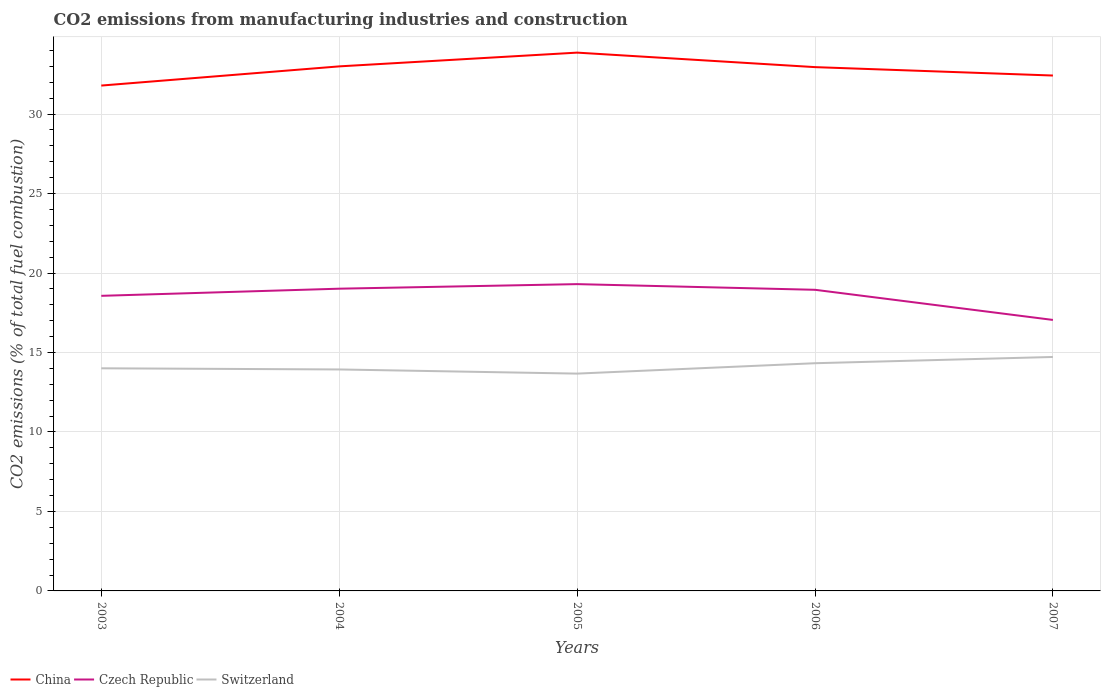How many different coloured lines are there?
Your response must be concise. 3. Does the line corresponding to Czech Republic intersect with the line corresponding to China?
Offer a terse response. No. Across all years, what is the maximum amount of CO2 emitted in Switzerland?
Offer a terse response. 13.67. In which year was the amount of CO2 emitted in Czech Republic maximum?
Make the answer very short. 2007. What is the total amount of CO2 emitted in Czech Republic in the graph?
Offer a very short reply. -0.29. What is the difference between the highest and the second highest amount of CO2 emitted in Czech Republic?
Offer a terse response. 2.25. How many lines are there?
Provide a short and direct response. 3. Are the values on the major ticks of Y-axis written in scientific E-notation?
Keep it short and to the point. No. Does the graph contain any zero values?
Keep it short and to the point. No. Does the graph contain grids?
Keep it short and to the point. Yes. Where does the legend appear in the graph?
Provide a short and direct response. Bottom left. How many legend labels are there?
Offer a terse response. 3. What is the title of the graph?
Your response must be concise. CO2 emissions from manufacturing industries and construction. Does "Pakistan" appear as one of the legend labels in the graph?
Your answer should be very brief. No. What is the label or title of the Y-axis?
Offer a very short reply. CO2 emissions (% of total fuel combustion). What is the CO2 emissions (% of total fuel combustion) of China in 2003?
Provide a succinct answer. 31.79. What is the CO2 emissions (% of total fuel combustion) of Czech Republic in 2003?
Your response must be concise. 18.56. What is the CO2 emissions (% of total fuel combustion) in Switzerland in 2003?
Offer a very short reply. 14.01. What is the CO2 emissions (% of total fuel combustion) of China in 2004?
Give a very brief answer. 33. What is the CO2 emissions (% of total fuel combustion) in Czech Republic in 2004?
Make the answer very short. 19.01. What is the CO2 emissions (% of total fuel combustion) of Switzerland in 2004?
Your answer should be very brief. 13.93. What is the CO2 emissions (% of total fuel combustion) of China in 2005?
Your answer should be compact. 33.86. What is the CO2 emissions (% of total fuel combustion) in Czech Republic in 2005?
Ensure brevity in your answer.  19.3. What is the CO2 emissions (% of total fuel combustion) of Switzerland in 2005?
Your response must be concise. 13.67. What is the CO2 emissions (% of total fuel combustion) in China in 2006?
Offer a terse response. 32.95. What is the CO2 emissions (% of total fuel combustion) of Czech Republic in 2006?
Your response must be concise. 18.94. What is the CO2 emissions (% of total fuel combustion) in Switzerland in 2006?
Provide a short and direct response. 14.32. What is the CO2 emissions (% of total fuel combustion) in China in 2007?
Make the answer very short. 32.42. What is the CO2 emissions (% of total fuel combustion) of Czech Republic in 2007?
Your answer should be compact. 17.05. What is the CO2 emissions (% of total fuel combustion) of Switzerland in 2007?
Your answer should be very brief. 14.72. Across all years, what is the maximum CO2 emissions (% of total fuel combustion) of China?
Provide a succinct answer. 33.86. Across all years, what is the maximum CO2 emissions (% of total fuel combustion) in Czech Republic?
Your response must be concise. 19.3. Across all years, what is the maximum CO2 emissions (% of total fuel combustion) of Switzerland?
Your answer should be compact. 14.72. Across all years, what is the minimum CO2 emissions (% of total fuel combustion) of China?
Your answer should be very brief. 31.79. Across all years, what is the minimum CO2 emissions (% of total fuel combustion) of Czech Republic?
Your answer should be very brief. 17.05. Across all years, what is the minimum CO2 emissions (% of total fuel combustion) in Switzerland?
Give a very brief answer. 13.67. What is the total CO2 emissions (% of total fuel combustion) in China in the graph?
Provide a short and direct response. 164.03. What is the total CO2 emissions (% of total fuel combustion) in Czech Republic in the graph?
Your response must be concise. 92.87. What is the total CO2 emissions (% of total fuel combustion) in Switzerland in the graph?
Offer a terse response. 70.65. What is the difference between the CO2 emissions (% of total fuel combustion) of China in 2003 and that in 2004?
Provide a succinct answer. -1.21. What is the difference between the CO2 emissions (% of total fuel combustion) of Czech Republic in 2003 and that in 2004?
Offer a terse response. -0.45. What is the difference between the CO2 emissions (% of total fuel combustion) of Switzerland in 2003 and that in 2004?
Your answer should be very brief. 0.07. What is the difference between the CO2 emissions (% of total fuel combustion) of China in 2003 and that in 2005?
Ensure brevity in your answer.  -2.07. What is the difference between the CO2 emissions (% of total fuel combustion) in Czech Republic in 2003 and that in 2005?
Provide a short and direct response. -0.74. What is the difference between the CO2 emissions (% of total fuel combustion) of Switzerland in 2003 and that in 2005?
Offer a very short reply. 0.33. What is the difference between the CO2 emissions (% of total fuel combustion) in China in 2003 and that in 2006?
Your response must be concise. -1.16. What is the difference between the CO2 emissions (% of total fuel combustion) in Czech Republic in 2003 and that in 2006?
Your response must be concise. -0.38. What is the difference between the CO2 emissions (% of total fuel combustion) of Switzerland in 2003 and that in 2006?
Give a very brief answer. -0.32. What is the difference between the CO2 emissions (% of total fuel combustion) of China in 2003 and that in 2007?
Your answer should be very brief. -0.63. What is the difference between the CO2 emissions (% of total fuel combustion) in Czech Republic in 2003 and that in 2007?
Provide a succinct answer. 1.52. What is the difference between the CO2 emissions (% of total fuel combustion) in Switzerland in 2003 and that in 2007?
Give a very brief answer. -0.71. What is the difference between the CO2 emissions (% of total fuel combustion) of China in 2004 and that in 2005?
Your answer should be very brief. -0.87. What is the difference between the CO2 emissions (% of total fuel combustion) in Czech Republic in 2004 and that in 2005?
Provide a short and direct response. -0.29. What is the difference between the CO2 emissions (% of total fuel combustion) of Switzerland in 2004 and that in 2005?
Your answer should be very brief. 0.26. What is the difference between the CO2 emissions (% of total fuel combustion) in China in 2004 and that in 2006?
Ensure brevity in your answer.  0.05. What is the difference between the CO2 emissions (% of total fuel combustion) of Czech Republic in 2004 and that in 2006?
Offer a terse response. 0.07. What is the difference between the CO2 emissions (% of total fuel combustion) of Switzerland in 2004 and that in 2006?
Provide a succinct answer. -0.39. What is the difference between the CO2 emissions (% of total fuel combustion) of China in 2004 and that in 2007?
Offer a terse response. 0.58. What is the difference between the CO2 emissions (% of total fuel combustion) of Czech Republic in 2004 and that in 2007?
Offer a terse response. 1.97. What is the difference between the CO2 emissions (% of total fuel combustion) in Switzerland in 2004 and that in 2007?
Make the answer very short. -0.79. What is the difference between the CO2 emissions (% of total fuel combustion) in China in 2005 and that in 2006?
Give a very brief answer. 0.91. What is the difference between the CO2 emissions (% of total fuel combustion) in Czech Republic in 2005 and that in 2006?
Ensure brevity in your answer.  0.36. What is the difference between the CO2 emissions (% of total fuel combustion) of Switzerland in 2005 and that in 2006?
Offer a very short reply. -0.65. What is the difference between the CO2 emissions (% of total fuel combustion) in China in 2005 and that in 2007?
Ensure brevity in your answer.  1.44. What is the difference between the CO2 emissions (% of total fuel combustion) of Czech Republic in 2005 and that in 2007?
Offer a terse response. 2.25. What is the difference between the CO2 emissions (% of total fuel combustion) of Switzerland in 2005 and that in 2007?
Your answer should be compact. -1.05. What is the difference between the CO2 emissions (% of total fuel combustion) in China in 2006 and that in 2007?
Provide a short and direct response. 0.53. What is the difference between the CO2 emissions (% of total fuel combustion) of Czech Republic in 2006 and that in 2007?
Your answer should be very brief. 1.9. What is the difference between the CO2 emissions (% of total fuel combustion) in Switzerland in 2006 and that in 2007?
Provide a short and direct response. -0.39. What is the difference between the CO2 emissions (% of total fuel combustion) in China in 2003 and the CO2 emissions (% of total fuel combustion) in Czech Republic in 2004?
Keep it short and to the point. 12.78. What is the difference between the CO2 emissions (% of total fuel combustion) in China in 2003 and the CO2 emissions (% of total fuel combustion) in Switzerland in 2004?
Offer a terse response. 17.86. What is the difference between the CO2 emissions (% of total fuel combustion) in Czech Republic in 2003 and the CO2 emissions (% of total fuel combustion) in Switzerland in 2004?
Your answer should be compact. 4.63. What is the difference between the CO2 emissions (% of total fuel combustion) of China in 2003 and the CO2 emissions (% of total fuel combustion) of Czech Republic in 2005?
Keep it short and to the point. 12.49. What is the difference between the CO2 emissions (% of total fuel combustion) in China in 2003 and the CO2 emissions (% of total fuel combustion) in Switzerland in 2005?
Provide a succinct answer. 18.12. What is the difference between the CO2 emissions (% of total fuel combustion) of Czech Republic in 2003 and the CO2 emissions (% of total fuel combustion) of Switzerland in 2005?
Your response must be concise. 4.89. What is the difference between the CO2 emissions (% of total fuel combustion) in China in 2003 and the CO2 emissions (% of total fuel combustion) in Czech Republic in 2006?
Provide a short and direct response. 12.85. What is the difference between the CO2 emissions (% of total fuel combustion) of China in 2003 and the CO2 emissions (% of total fuel combustion) of Switzerland in 2006?
Provide a short and direct response. 17.47. What is the difference between the CO2 emissions (% of total fuel combustion) in Czech Republic in 2003 and the CO2 emissions (% of total fuel combustion) in Switzerland in 2006?
Make the answer very short. 4.24. What is the difference between the CO2 emissions (% of total fuel combustion) of China in 2003 and the CO2 emissions (% of total fuel combustion) of Czech Republic in 2007?
Offer a terse response. 14.74. What is the difference between the CO2 emissions (% of total fuel combustion) in China in 2003 and the CO2 emissions (% of total fuel combustion) in Switzerland in 2007?
Your response must be concise. 17.07. What is the difference between the CO2 emissions (% of total fuel combustion) of Czech Republic in 2003 and the CO2 emissions (% of total fuel combustion) of Switzerland in 2007?
Your answer should be compact. 3.85. What is the difference between the CO2 emissions (% of total fuel combustion) in China in 2004 and the CO2 emissions (% of total fuel combustion) in Czech Republic in 2005?
Give a very brief answer. 13.7. What is the difference between the CO2 emissions (% of total fuel combustion) of China in 2004 and the CO2 emissions (% of total fuel combustion) of Switzerland in 2005?
Your response must be concise. 19.33. What is the difference between the CO2 emissions (% of total fuel combustion) of Czech Republic in 2004 and the CO2 emissions (% of total fuel combustion) of Switzerland in 2005?
Ensure brevity in your answer.  5.34. What is the difference between the CO2 emissions (% of total fuel combustion) of China in 2004 and the CO2 emissions (% of total fuel combustion) of Czech Republic in 2006?
Provide a short and direct response. 14.05. What is the difference between the CO2 emissions (% of total fuel combustion) in China in 2004 and the CO2 emissions (% of total fuel combustion) in Switzerland in 2006?
Ensure brevity in your answer.  18.67. What is the difference between the CO2 emissions (% of total fuel combustion) in Czech Republic in 2004 and the CO2 emissions (% of total fuel combustion) in Switzerland in 2006?
Your answer should be compact. 4.69. What is the difference between the CO2 emissions (% of total fuel combustion) in China in 2004 and the CO2 emissions (% of total fuel combustion) in Czech Republic in 2007?
Your response must be concise. 15.95. What is the difference between the CO2 emissions (% of total fuel combustion) of China in 2004 and the CO2 emissions (% of total fuel combustion) of Switzerland in 2007?
Offer a terse response. 18.28. What is the difference between the CO2 emissions (% of total fuel combustion) in Czech Republic in 2004 and the CO2 emissions (% of total fuel combustion) in Switzerland in 2007?
Make the answer very short. 4.3. What is the difference between the CO2 emissions (% of total fuel combustion) in China in 2005 and the CO2 emissions (% of total fuel combustion) in Czech Republic in 2006?
Your response must be concise. 14.92. What is the difference between the CO2 emissions (% of total fuel combustion) in China in 2005 and the CO2 emissions (% of total fuel combustion) in Switzerland in 2006?
Your answer should be very brief. 19.54. What is the difference between the CO2 emissions (% of total fuel combustion) in Czech Republic in 2005 and the CO2 emissions (% of total fuel combustion) in Switzerland in 2006?
Provide a short and direct response. 4.98. What is the difference between the CO2 emissions (% of total fuel combustion) of China in 2005 and the CO2 emissions (% of total fuel combustion) of Czech Republic in 2007?
Make the answer very short. 16.82. What is the difference between the CO2 emissions (% of total fuel combustion) of China in 2005 and the CO2 emissions (% of total fuel combustion) of Switzerland in 2007?
Your answer should be very brief. 19.15. What is the difference between the CO2 emissions (% of total fuel combustion) of Czech Republic in 2005 and the CO2 emissions (% of total fuel combustion) of Switzerland in 2007?
Give a very brief answer. 4.58. What is the difference between the CO2 emissions (% of total fuel combustion) of China in 2006 and the CO2 emissions (% of total fuel combustion) of Czech Republic in 2007?
Your answer should be very brief. 15.9. What is the difference between the CO2 emissions (% of total fuel combustion) in China in 2006 and the CO2 emissions (% of total fuel combustion) in Switzerland in 2007?
Ensure brevity in your answer.  18.23. What is the difference between the CO2 emissions (% of total fuel combustion) in Czech Republic in 2006 and the CO2 emissions (% of total fuel combustion) in Switzerland in 2007?
Your answer should be compact. 4.23. What is the average CO2 emissions (% of total fuel combustion) in China per year?
Your answer should be compact. 32.81. What is the average CO2 emissions (% of total fuel combustion) in Czech Republic per year?
Provide a succinct answer. 18.57. What is the average CO2 emissions (% of total fuel combustion) in Switzerland per year?
Ensure brevity in your answer.  14.13. In the year 2003, what is the difference between the CO2 emissions (% of total fuel combustion) of China and CO2 emissions (% of total fuel combustion) of Czech Republic?
Offer a very short reply. 13.23. In the year 2003, what is the difference between the CO2 emissions (% of total fuel combustion) of China and CO2 emissions (% of total fuel combustion) of Switzerland?
Provide a short and direct response. 17.79. In the year 2003, what is the difference between the CO2 emissions (% of total fuel combustion) of Czech Republic and CO2 emissions (% of total fuel combustion) of Switzerland?
Offer a very short reply. 4.56. In the year 2004, what is the difference between the CO2 emissions (% of total fuel combustion) in China and CO2 emissions (% of total fuel combustion) in Czech Republic?
Provide a short and direct response. 13.99. In the year 2004, what is the difference between the CO2 emissions (% of total fuel combustion) of China and CO2 emissions (% of total fuel combustion) of Switzerland?
Offer a terse response. 19.07. In the year 2004, what is the difference between the CO2 emissions (% of total fuel combustion) of Czech Republic and CO2 emissions (% of total fuel combustion) of Switzerland?
Ensure brevity in your answer.  5.08. In the year 2005, what is the difference between the CO2 emissions (% of total fuel combustion) of China and CO2 emissions (% of total fuel combustion) of Czech Republic?
Offer a very short reply. 14.56. In the year 2005, what is the difference between the CO2 emissions (% of total fuel combustion) of China and CO2 emissions (% of total fuel combustion) of Switzerland?
Your response must be concise. 20.19. In the year 2005, what is the difference between the CO2 emissions (% of total fuel combustion) of Czech Republic and CO2 emissions (% of total fuel combustion) of Switzerland?
Your answer should be compact. 5.63. In the year 2006, what is the difference between the CO2 emissions (% of total fuel combustion) of China and CO2 emissions (% of total fuel combustion) of Czech Republic?
Your answer should be compact. 14.01. In the year 2006, what is the difference between the CO2 emissions (% of total fuel combustion) in China and CO2 emissions (% of total fuel combustion) in Switzerland?
Offer a terse response. 18.63. In the year 2006, what is the difference between the CO2 emissions (% of total fuel combustion) of Czech Republic and CO2 emissions (% of total fuel combustion) of Switzerland?
Your answer should be very brief. 4.62. In the year 2007, what is the difference between the CO2 emissions (% of total fuel combustion) of China and CO2 emissions (% of total fuel combustion) of Czech Republic?
Keep it short and to the point. 15.38. In the year 2007, what is the difference between the CO2 emissions (% of total fuel combustion) of China and CO2 emissions (% of total fuel combustion) of Switzerland?
Provide a short and direct response. 17.71. In the year 2007, what is the difference between the CO2 emissions (% of total fuel combustion) in Czech Republic and CO2 emissions (% of total fuel combustion) in Switzerland?
Your response must be concise. 2.33. What is the ratio of the CO2 emissions (% of total fuel combustion) of China in 2003 to that in 2004?
Your answer should be very brief. 0.96. What is the ratio of the CO2 emissions (% of total fuel combustion) in Czech Republic in 2003 to that in 2004?
Your answer should be compact. 0.98. What is the ratio of the CO2 emissions (% of total fuel combustion) of Switzerland in 2003 to that in 2004?
Offer a very short reply. 1.01. What is the ratio of the CO2 emissions (% of total fuel combustion) in China in 2003 to that in 2005?
Make the answer very short. 0.94. What is the ratio of the CO2 emissions (% of total fuel combustion) of Czech Republic in 2003 to that in 2005?
Provide a succinct answer. 0.96. What is the ratio of the CO2 emissions (% of total fuel combustion) of Switzerland in 2003 to that in 2005?
Provide a short and direct response. 1.02. What is the ratio of the CO2 emissions (% of total fuel combustion) in China in 2003 to that in 2006?
Keep it short and to the point. 0.96. What is the ratio of the CO2 emissions (% of total fuel combustion) in Czech Republic in 2003 to that in 2006?
Ensure brevity in your answer.  0.98. What is the ratio of the CO2 emissions (% of total fuel combustion) of Switzerland in 2003 to that in 2006?
Offer a very short reply. 0.98. What is the ratio of the CO2 emissions (% of total fuel combustion) in China in 2003 to that in 2007?
Offer a very short reply. 0.98. What is the ratio of the CO2 emissions (% of total fuel combustion) of Czech Republic in 2003 to that in 2007?
Ensure brevity in your answer.  1.09. What is the ratio of the CO2 emissions (% of total fuel combustion) in Switzerland in 2003 to that in 2007?
Offer a terse response. 0.95. What is the ratio of the CO2 emissions (% of total fuel combustion) of China in 2004 to that in 2005?
Give a very brief answer. 0.97. What is the ratio of the CO2 emissions (% of total fuel combustion) in Czech Republic in 2004 to that in 2005?
Your response must be concise. 0.99. What is the ratio of the CO2 emissions (% of total fuel combustion) in Switzerland in 2004 to that in 2005?
Provide a succinct answer. 1.02. What is the ratio of the CO2 emissions (% of total fuel combustion) in China in 2004 to that in 2006?
Keep it short and to the point. 1. What is the ratio of the CO2 emissions (% of total fuel combustion) of Switzerland in 2004 to that in 2006?
Ensure brevity in your answer.  0.97. What is the ratio of the CO2 emissions (% of total fuel combustion) of China in 2004 to that in 2007?
Offer a terse response. 1.02. What is the ratio of the CO2 emissions (% of total fuel combustion) of Czech Republic in 2004 to that in 2007?
Your answer should be compact. 1.12. What is the ratio of the CO2 emissions (% of total fuel combustion) of Switzerland in 2004 to that in 2007?
Provide a succinct answer. 0.95. What is the ratio of the CO2 emissions (% of total fuel combustion) in China in 2005 to that in 2006?
Make the answer very short. 1.03. What is the ratio of the CO2 emissions (% of total fuel combustion) in Czech Republic in 2005 to that in 2006?
Ensure brevity in your answer.  1.02. What is the ratio of the CO2 emissions (% of total fuel combustion) in Switzerland in 2005 to that in 2006?
Keep it short and to the point. 0.95. What is the ratio of the CO2 emissions (% of total fuel combustion) in China in 2005 to that in 2007?
Offer a terse response. 1.04. What is the ratio of the CO2 emissions (% of total fuel combustion) of Czech Republic in 2005 to that in 2007?
Ensure brevity in your answer.  1.13. What is the ratio of the CO2 emissions (% of total fuel combustion) in Switzerland in 2005 to that in 2007?
Provide a short and direct response. 0.93. What is the ratio of the CO2 emissions (% of total fuel combustion) of China in 2006 to that in 2007?
Keep it short and to the point. 1.02. What is the ratio of the CO2 emissions (% of total fuel combustion) of Czech Republic in 2006 to that in 2007?
Provide a short and direct response. 1.11. What is the ratio of the CO2 emissions (% of total fuel combustion) of Switzerland in 2006 to that in 2007?
Make the answer very short. 0.97. What is the difference between the highest and the second highest CO2 emissions (% of total fuel combustion) in China?
Ensure brevity in your answer.  0.87. What is the difference between the highest and the second highest CO2 emissions (% of total fuel combustion) in Czech Republic?
Your response must be concise. 0.29. What is the difference between the highest and the second highest CO2 emissions (% of total fuel combustion) of Switzerland?
Offer a very short reply. 0.39. What is the difference between the highest and the lowest CO2 emissions (% of total fuel combustion) of China?
Make the answer very short. 2.07. What is the difference between the highest and the lowest CO2 emissions (% of total fuel combustion) of Czech Republic?
Provide a short and direct response. 2.25. What is the difference between the highest and the lowest CO2 emissions (% of total fuel combustion) in Switzerland?
Keep it short and to the point. 1.05. 